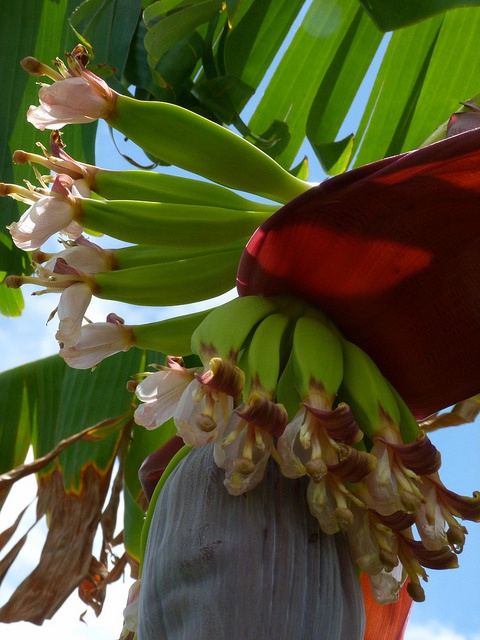Describe the objects in this image and their specific colors. I can see a banana in darkgreen, black, and maroon tones in this image. 